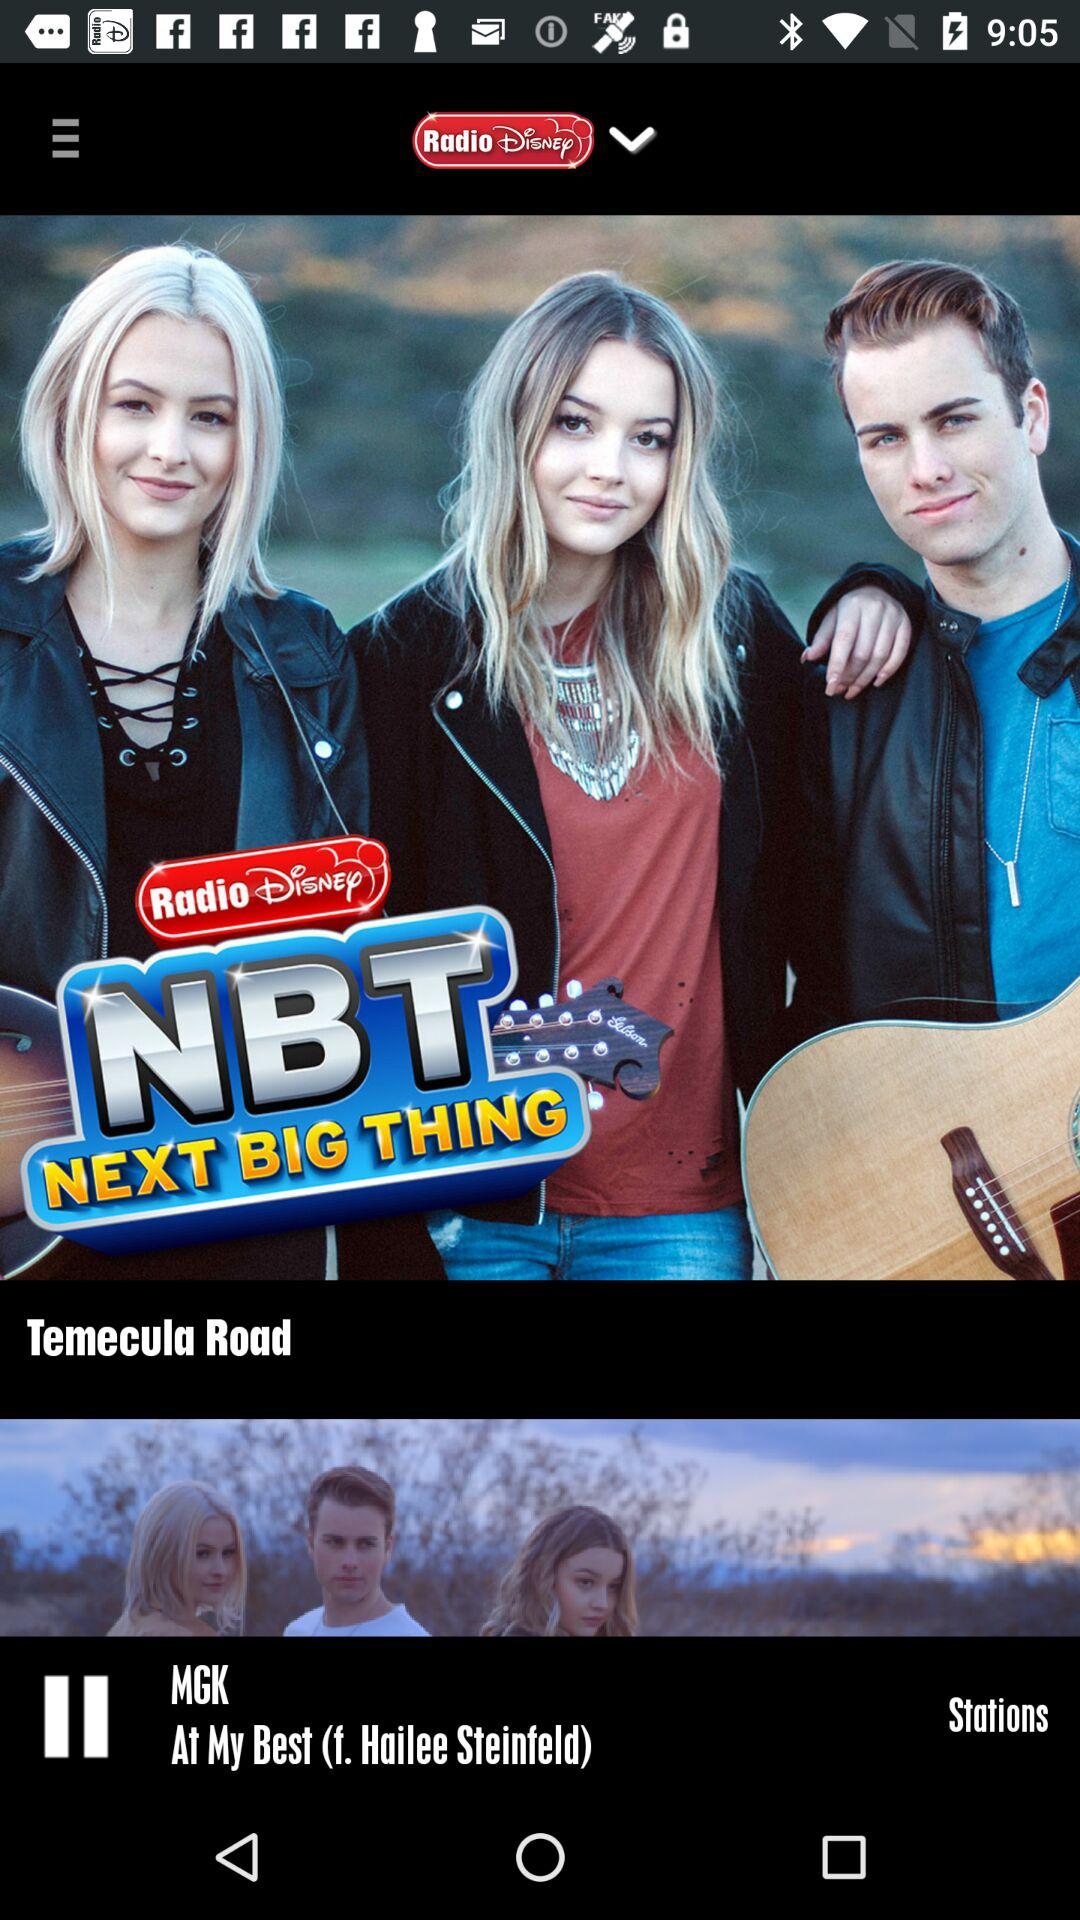What is the name of application? The name of the application is "Radio Disney". 